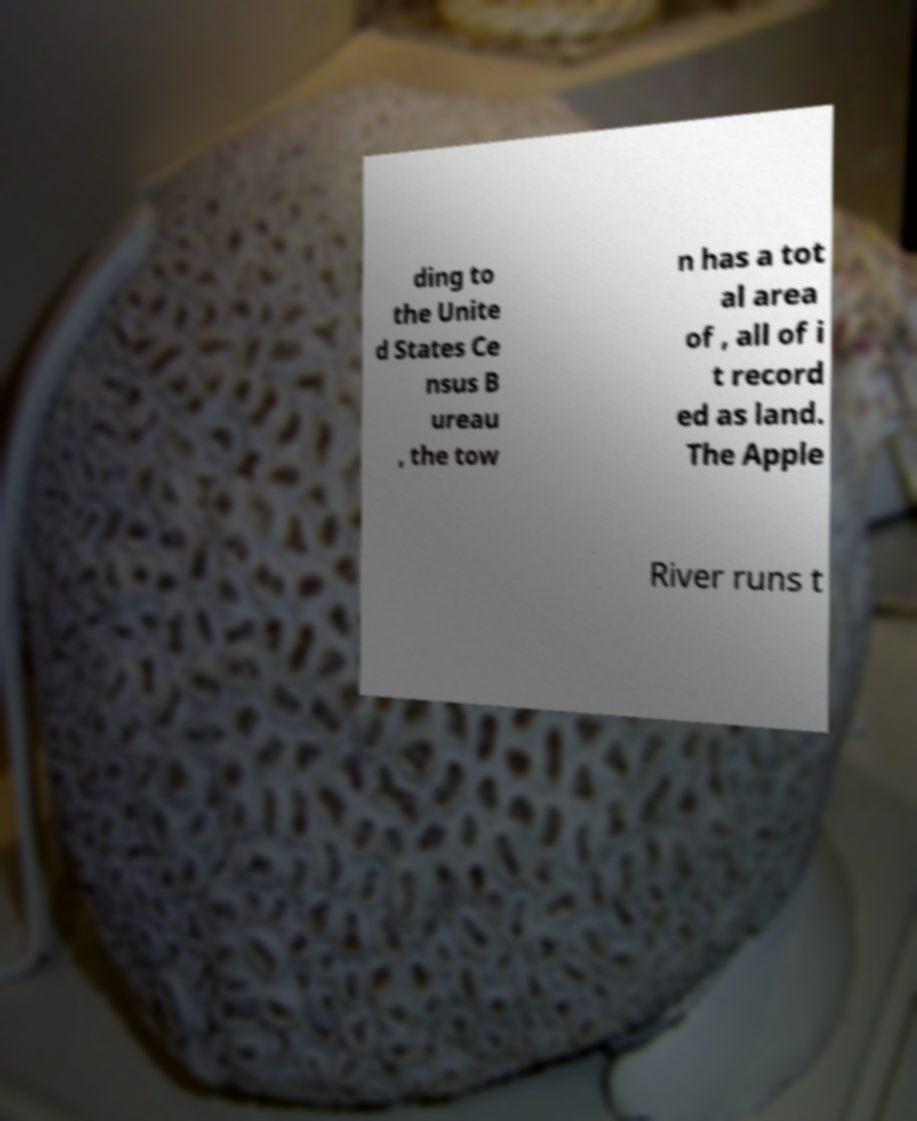What messages or text are displayed in this image? I need them in a readable, typed format. ding to the Unite d States Ce nsus B ureau , the tow n has a tot al area of , all of i t record ed as land. The Apple River runs t 